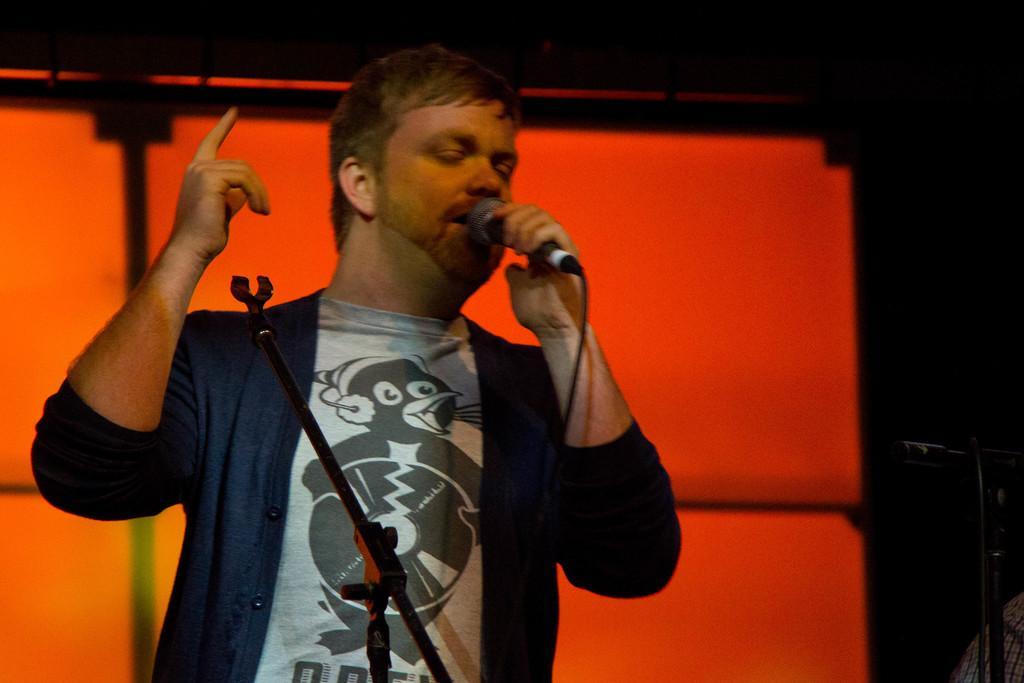Please provide a concise description of this image. In this image we can see a man standing and holding a mic and we can see the microphone stands and it looks like a screen in the background. 